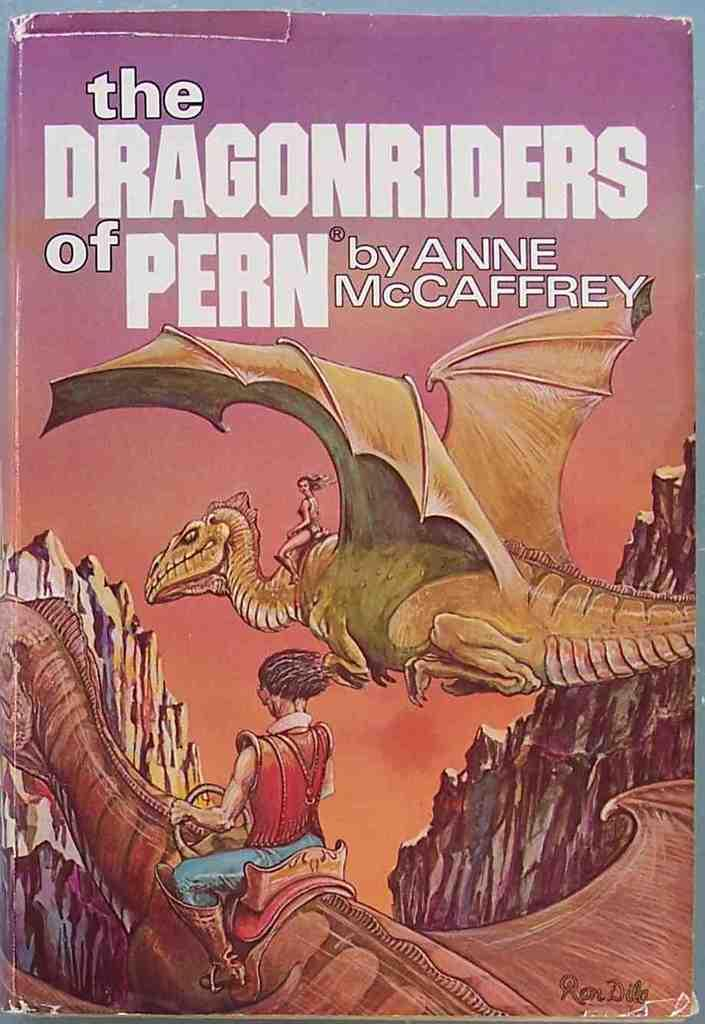<image>
Offer a succinct explanation of the picture presented. A fantasy novel titled The Dragonriders of Pern written presumably for young adults. 